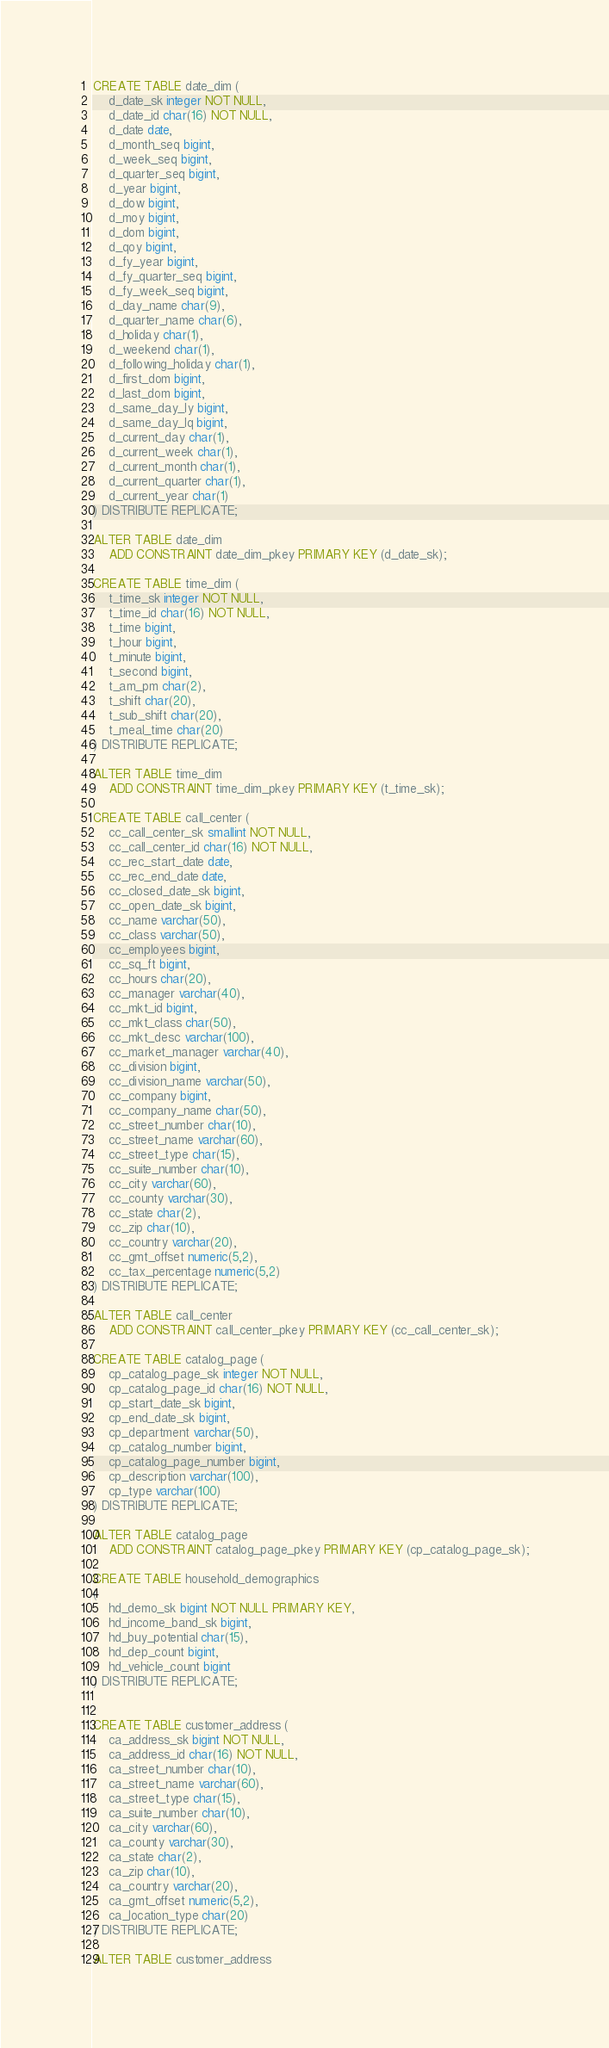Convert code to text. <code><loc_0><loc_0><loc_500><loc_500><_SQL_>CREATE TABLE date_dim (
    d_date_sk integer NOT NULL,
    d_date_id char(16) NOT NULL,
    d_date date,
    d_month_seq bigint,
    d_week_seq bigint,
    d_quarter_seq bigint,
    d_year bigint,
    d_dow bigint,
    d_moy bigint,
    d_dom bigint,
    d_qoy bigint,
    d_fy_year bigint,
    d_fy_quarter_seq bigint,
    d_fy_week_seq bigint,
    d_day_name char(9),
    d_quarter_name char(6),
    d_holiday char(1),
    d_weekend char(1),
    d_following_holiday char(1),
    d_first_dom bigint,
    d_last_dom bigint,
    d_same_day_ly bigint,
    d_same_day_lq bigint,
    d_current_day char(1),
    d_current_week char(1),
    d_current_month char(1),
    d_current_quarter char(1),
    d_current_year char(1)
) DISTRIBUTE REPLICATE;

ALTER TABLE date_dim
    ADD CONSTRAINT date_dim_pkey PRIMARY KEY (d_date_sk);

CREATE TABLE time_dim (
    t_time_sk integer NOT NULL,
    t_time_id char(16) NOT NULL,
    t_time bigint,
    t_hour bigint,
    t_minute bigint,
    t_second bigint,
    t_am_pm char(2),
    t_shift char(20),
    t_sub_shift char(20),
    t_meal_time char(20)
) DISTRIBUTE REPLICATE;

ALTER TABLE time_dim
    ADD CONSTRAINT time_dim_pkey PRIMARY KEY (t_time_sk);

CREATE TABLE call_center (
    cc_call_center_sk smallint NOT NULL,
    cc_call_center_id char(16) NOT NULL,
    cc_rec_start_date date,
    cc_rec_end_date date,
    cc_closed_date_sk bigint,
    cc_open_date_sk bigint,
    cc_name varchar(50),
    cc_class varchar(50),
    cc_employees bigint,
    cc_sq_ft bigint,
    cc_hours char(20),
    cc_manager varchar(40),
    cc_mkt_id bigint,
    cc_mkt_class char(50),
    cc_mkt_desc varchar(100),
    cc_market_manager varchar(40),
    cc_division bigint,
    cc_division_name varchar(50),
    cc_company bigint,
    cc_company_name char(50),
    cc_street_number char(10),
    cc_street_name varchar(60),
    cc_street_type char(15),
    cc_suite_number char(10),
    cc_city varchar(60),
    cc_county varchar(30),
    cc_state char(2),
    cc_zip char(10),
    cc_country varchar(20),
    cc_gmt_offset numeric(5,2),
    cc_tax_percentage numeric(5,2)
) DISTRIBUTE REPLICATE;

ALTER TABLE call_center
    ADD CONSTRAINT call_center_pkey PRIMARY KEY (cc_call_center_sk);

CREATE TABLE catalog_page (
    cp_catalog_page_sk integer NOT NULL,
    cp_catalog_page_id char(16) NOT NULL,
    cp_start_date_sk bigint,
    cp_end_date_sk bigint,
    cp_department varchar(50),
    cp_catalog_number bigint,
    cp_catalog_page_number bigint,
    cp_description varchar(100),
    cp_type varchar(100)
) DISTRIBUTE REPLICATE;

ALTER TABLE catalog_page
    ADD CONSTRAINT catalog_page_pkey PRIMARY KEY (cp_catalog_page_sk);

CREATE TABLE household_demographics
(
    hd_demo_sk bigint NOT NULL PRIMARY KEY,
    hd_income_band_sk bigint,
    hd_buy_potential char(15),
    hd_dep_count bigint,
    hd_vehicle_count bigint
) DISTRIBUTE REPLICATE;


CREATE TABLE customer_address (
    ca_address_sk bigint NOT NULL,
    ca_address_id char(16) NOT NULL,
    ca_street_number char(10),
    ca_street_name varchar(60),
    ca_street_type char(15),
    ca_suite_number char(10),
    ca_city varchar(60),
    ca_county varchar(30),
    ca_state char(2),
    ca_zip char(10),
    ca_country varchar(20),
    ca_gmt_offset numeric(5,2),
    ca_location_type char(20)
) DISTRIBUTE REPLICATE;

ALTER TABLE customer_address</code> 